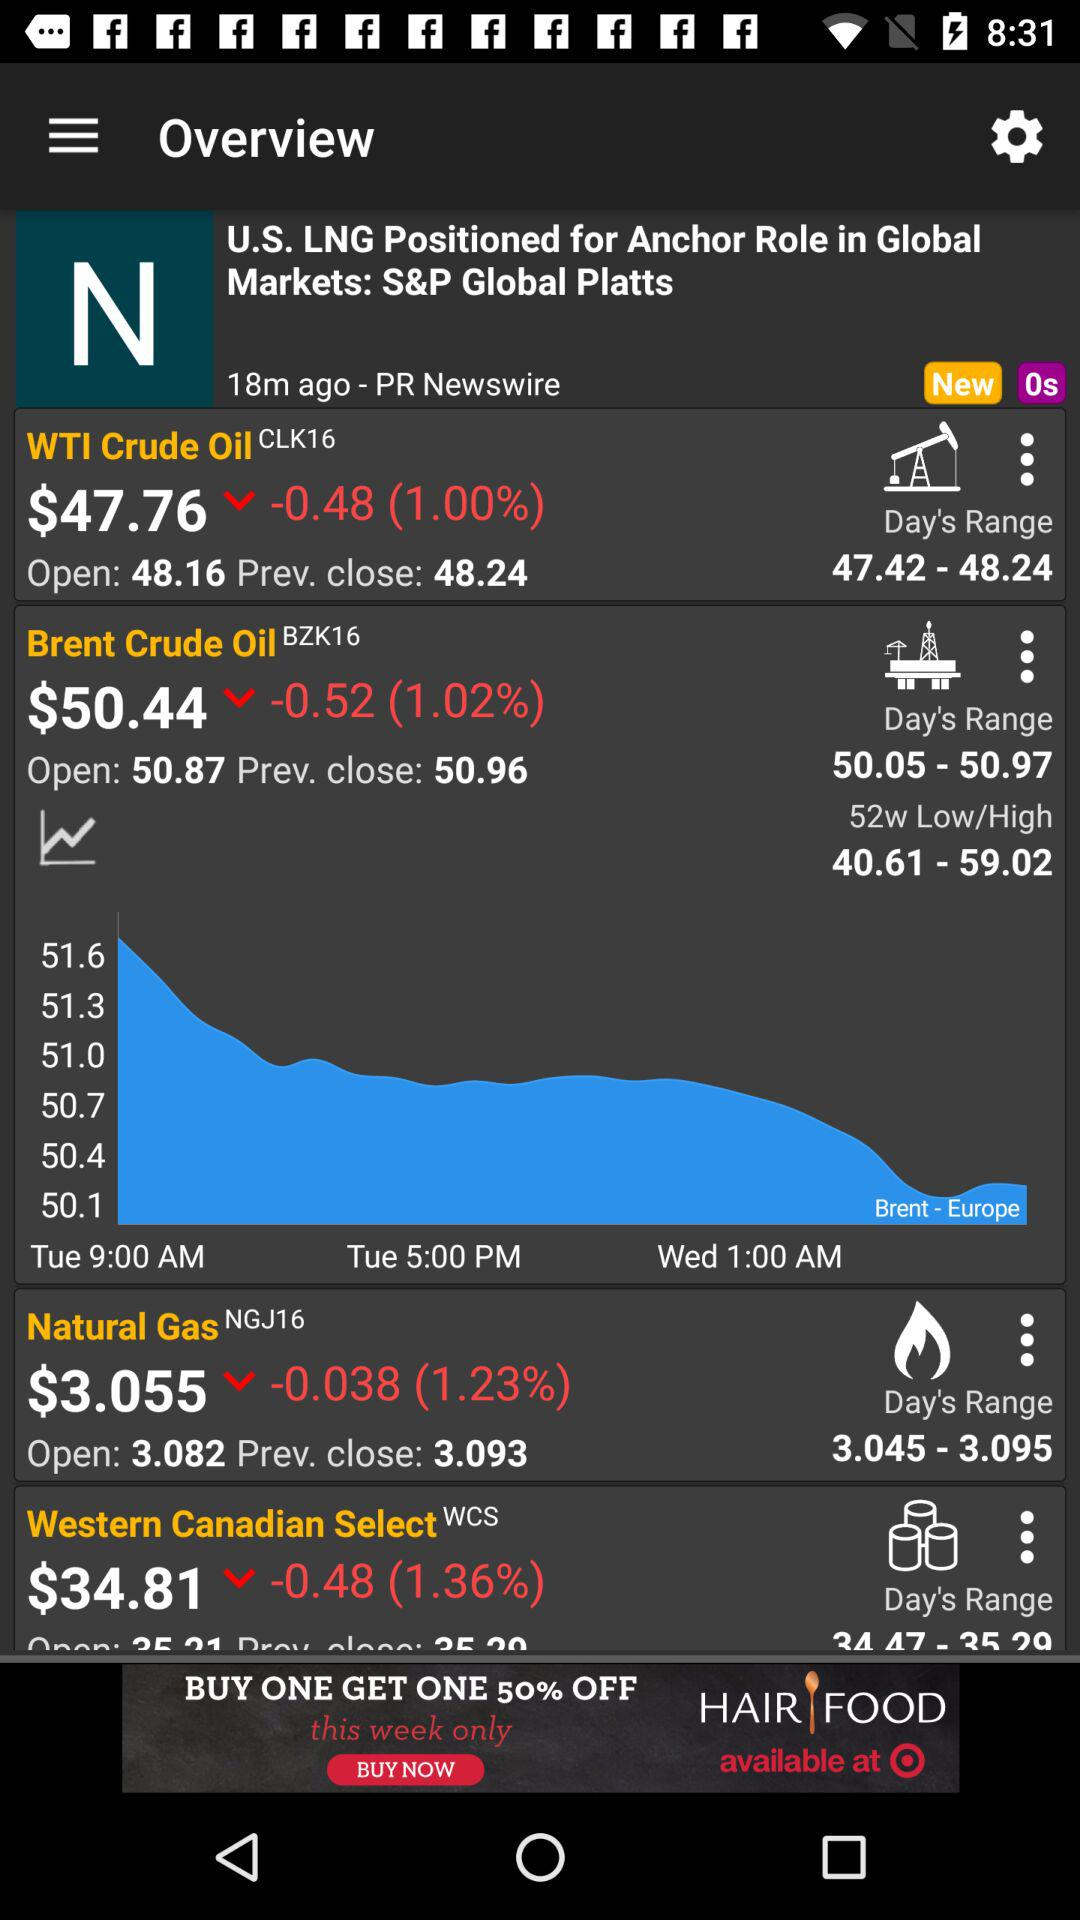At what value did the "WTI Crude Oil" share close? The "WTI Crude Oil" share closed at 48.24. 